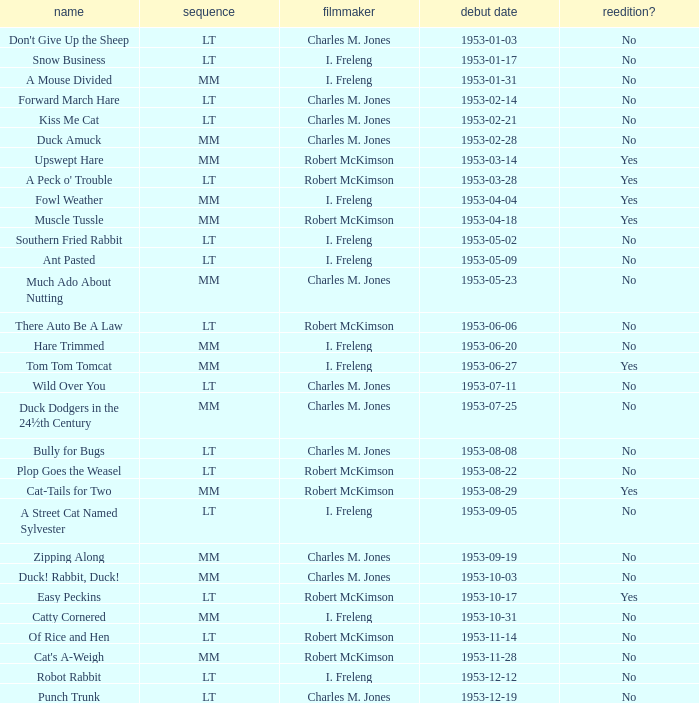What's the title for the release date of 1953-01-31 in the MM series, no reissue, and a director of I. Freleng? A Mouse Divided. 